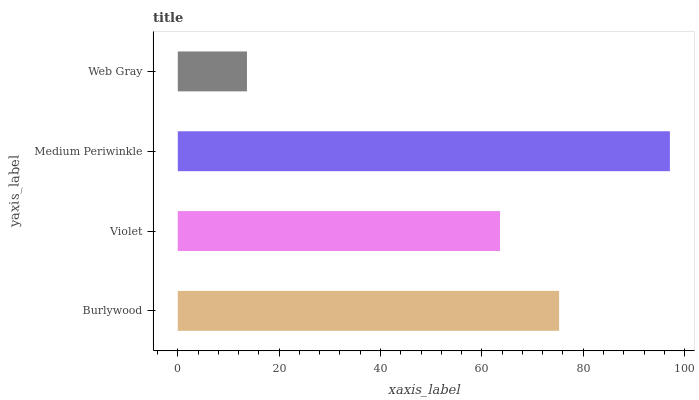Is Web Gray the minimum?
Answer yes or no. Yes. Is Medium Periwinkle the maximum?
Answer yes or no. Yes. Is Violet the minimum?
Answer yes or no. No. Is Violet the maximum?
Answer yes or no. No. Is Burlywood greater than Violet?
Answer yes or no. Yes. Is Violet less than Burlywood?
Answer yes or no. Yes. Is Violet greater than Burlywood?
Answer yes or no. No. Is Burlywood less than Violet?
Answer yes or no. No. Is Burlywood the high median?
Answer yes or no. Yes. Is Violet the low median?
Answer yes or no. Yes. Is Web Gray the high median?
Answer yes or no. No. Is Medium Periwinkle the low median?
Answer yes or no. No. 